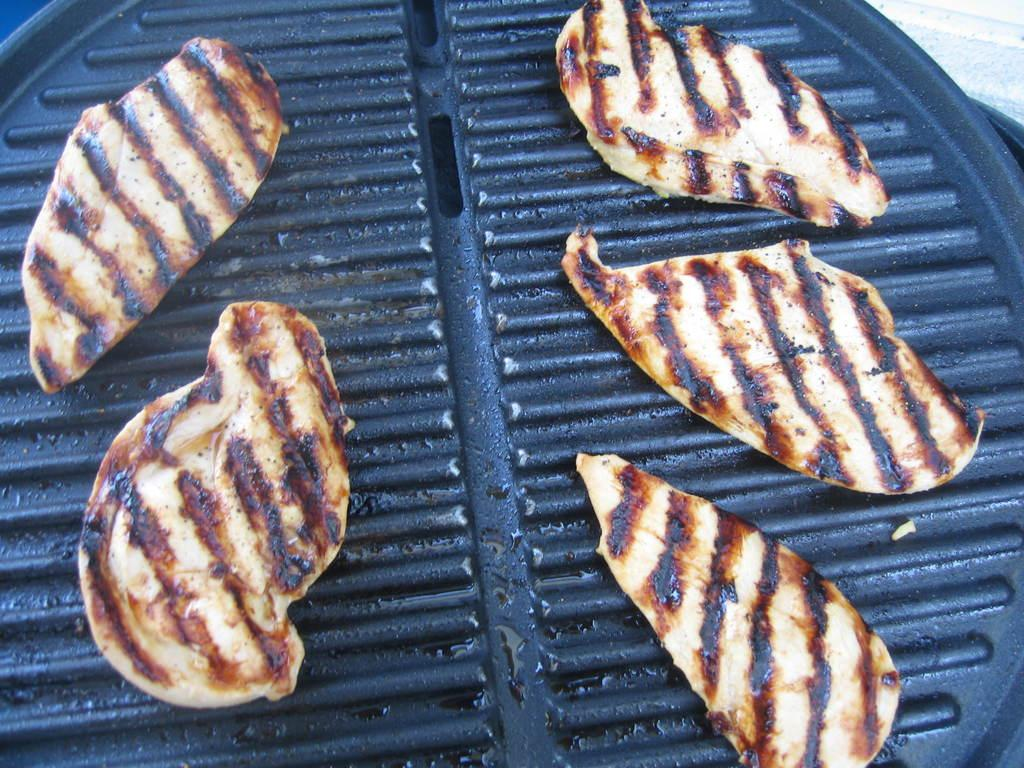What is the color of the grill in the image? The grill in the image is black colored. What is being cooked on the grill? There are pieces of meat on the grill. Can you describe the colors of the pieces of meat? The pieces of meat have cream, brown, and black colors. What type of button is being used to cook the meat in the image? There is no button present in the image; the grill is being used to cook the meat. Can you see any worms crawling on the pieces of meat in the image? There are no worms present in the image; only the grill and pieces of meat can be seen. 